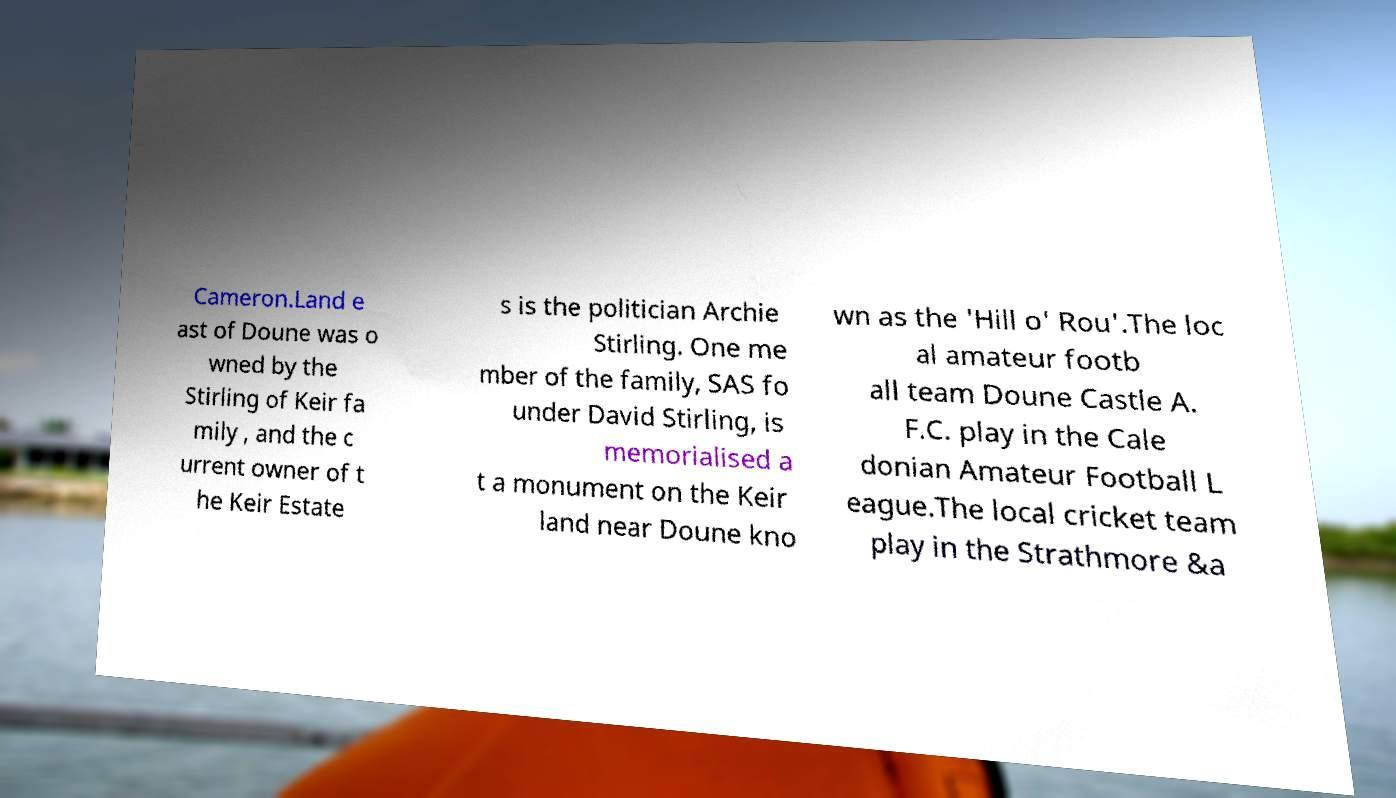There's text embedded in this image that I need extracted. Can you transcribe it verbatim? Cameron.Land e ast of Doune was o wned by the Stirling of Keir fa mily , and the c urrent owner of t he Keir Estate s is the politician Archie Stirling. One me mber of the family, SAS fo under David Stirling, is memorialised a t a monument on the Keir land near Doune kno wn as the 'Hill o' Rou'.The loc al amateur footb all team Doune Castle A. F.C. play in the Cale donian Amateur Football L eague.The local cricket team play in the Strathmore &a 